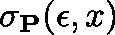<formula> <loc_0><loc_0><loc_500><loc_500>\sigma _ { P } ( \epsilon , x )</formula> 